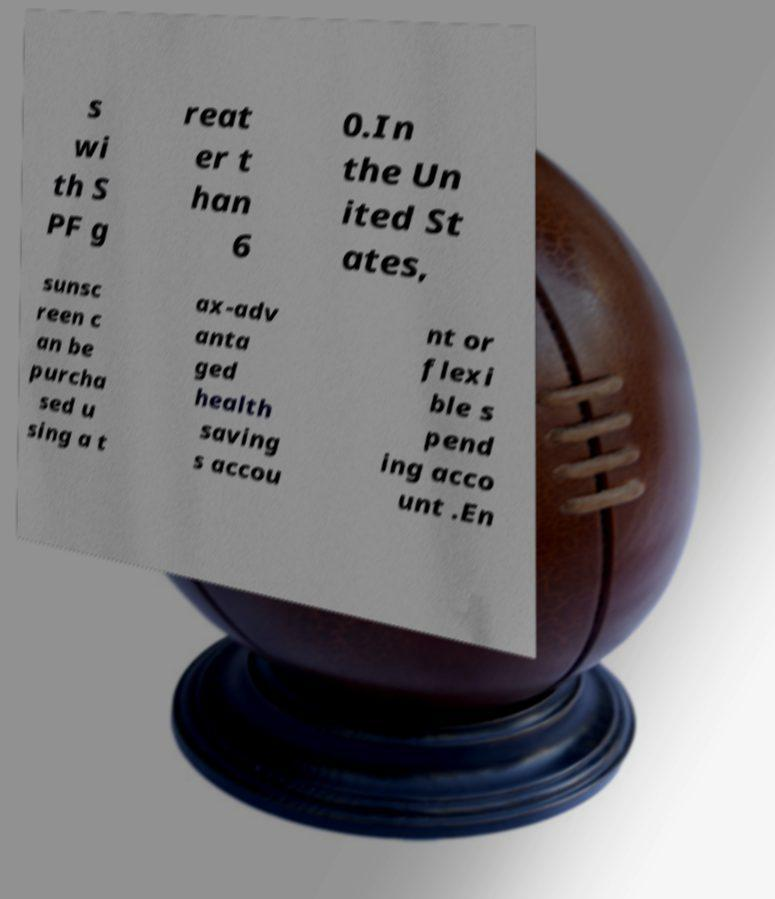Can you accurately transcribe the text from the provided image for me? s wi th S PF g reat er t han 6 0.In the Un ited St ates, sunsc reen c an be purcha sed u sing a t ax-adv anta ged health saving s accou nt or flexi ble s pend ing acco unt .En 